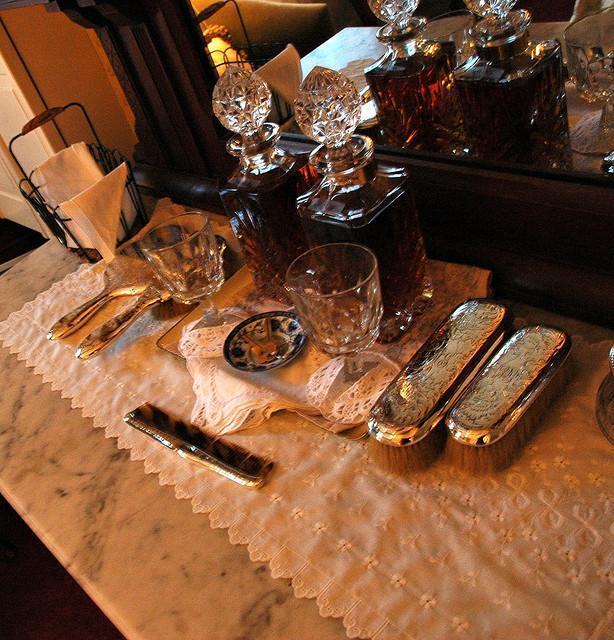How many people in the photo?
Give a very brief answer. 0. How many wine glasses are there?
Give a very brief answer. 3. How many bottles are there?
Give a very brief answer. 4. How many spoons are visible?
Give a very brief answer. 2. How many carrots are in the water?
Give a very brief answer. 0. 